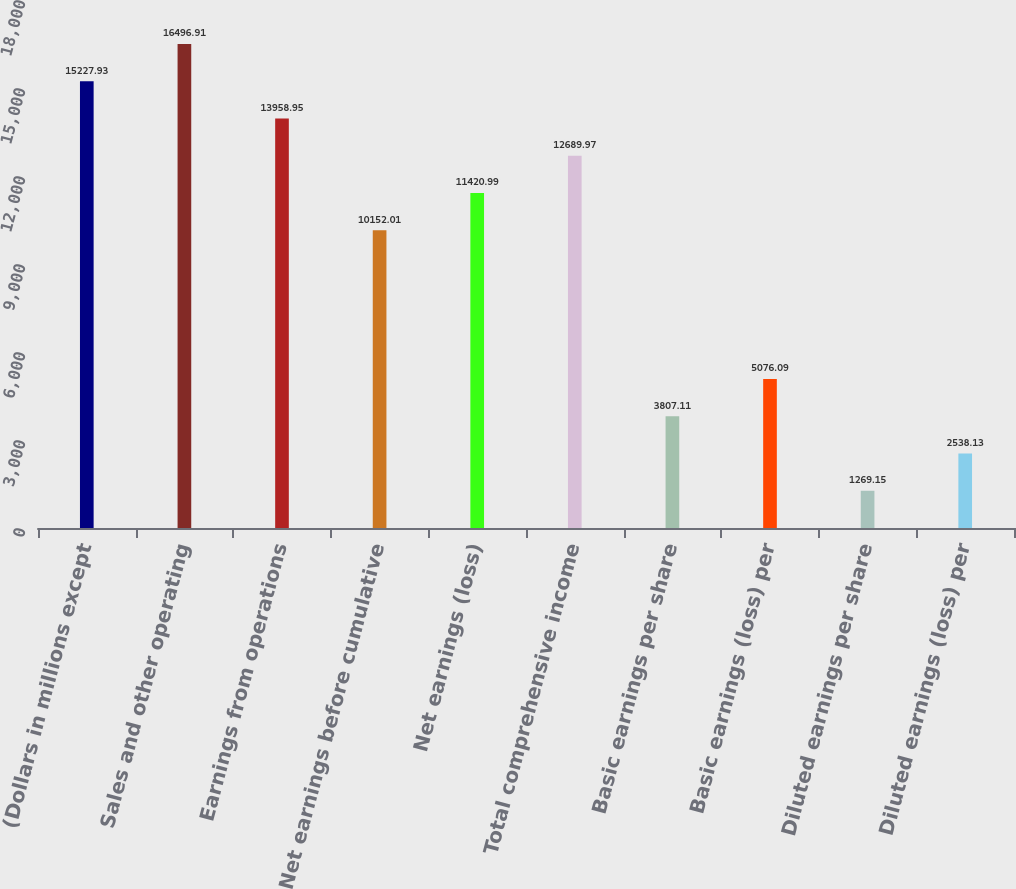Convert chart. <chart><loc_0><loc_0><loc_500><loc_500><bar_chart><fcel>(Dollars in millions except<fcel>Sales and other operating<fcel>Earnings from operations<fcel>Net earnings before cumulative<fcel>Net earnings (loss)<fcel>Total comprehensive income<fcel>Basic earnings per share<fcel>Basic earnings (loss) per<fcel>Diluted earnings per share<fcel>Diluted earnings (loss) per<nl><fcel>15227.9<fcel>16496.9<fcel>13959<fcel>10152<fcel>11421<fcel>12690<fcel>3807.11<fcel>5076.09<fcel>1269.15<fcel>2538.13<nl></chart> 